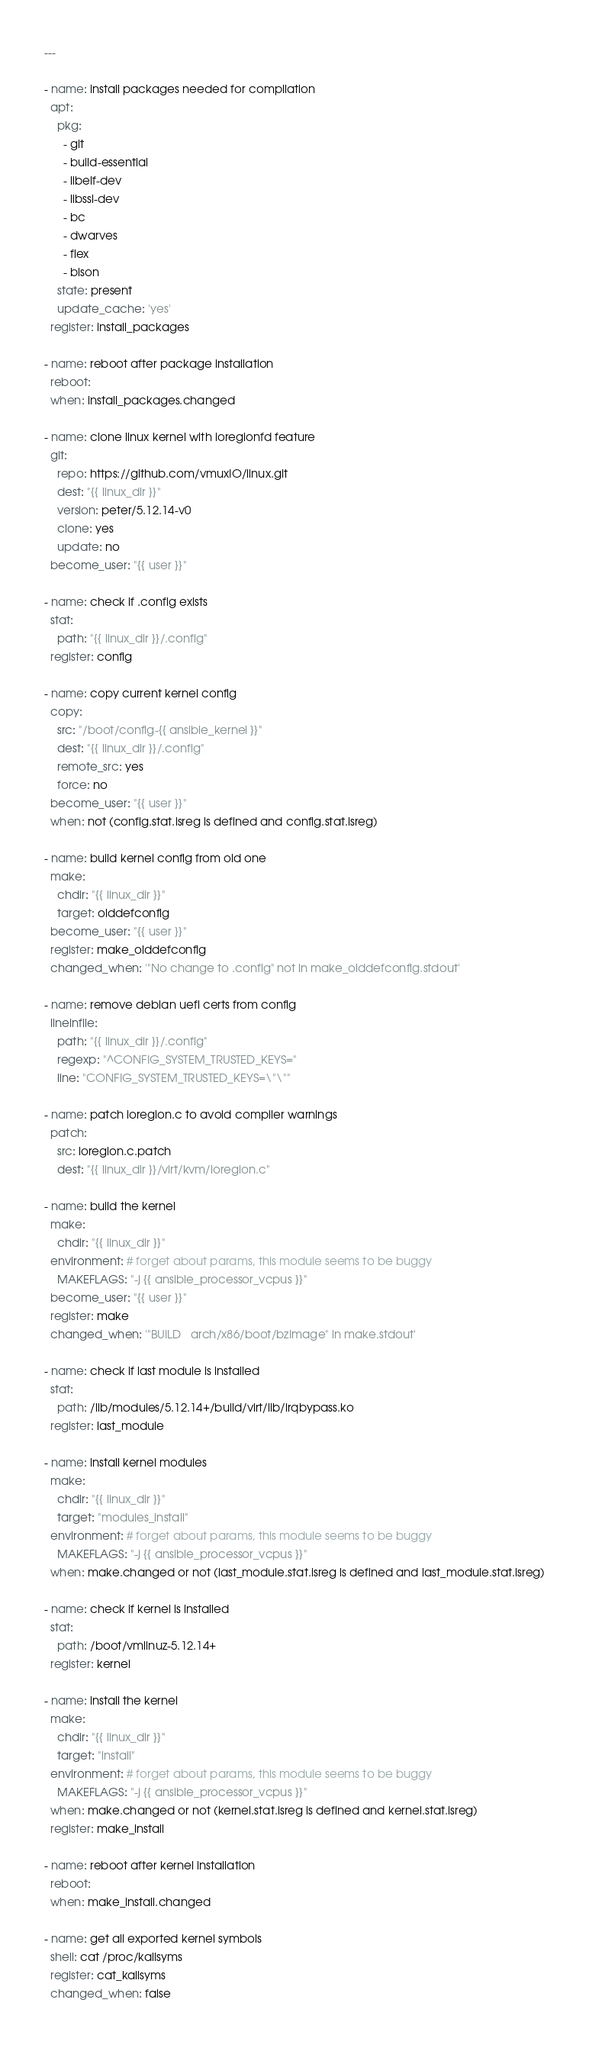Convert code to text. <code><loc_0><loc_0><loc_500><loc_500><_YAML_>---

- name: install packages needed for compilation
  apt:
    pkg:
      - git
      - build-essential
      - libelf-dev
      - libssl-dev
      - bc
      - dwarves
      - flex
      - bison
    state: present
    update_cache: 'yes'
  register: install_packages

- name: reboot after package installation
  reboot:
  when: install_packages.changed

- name: clone linux kernel with ioregionfd feature
  git:
    repo: https://github.com/vmuxIO/linux.git
    dest: "{{ linux_dir }}"
    version: peter/5.12.14-v0
    clone: yes
    update: no
  become_user: "{{ user }}"

- name: check if .config exists
  stat:
    path: "{{ linux_dir }}/.config"
  register: config

- name: copy current kernel config
  copy:
    src: "/boot/config-{{ ansible_kernel }}"
    dest: "{{ linux_dir }}/.config"
    remote_src: yes
    force: no
  become_user: "{{ user }}"
  when: not (config.stat.isreg is defined and config.stat.isreg)

- name: build kernel config from old one
  make:
    chdir: "{{ linux_dir }}"
    target: olddefconfig
  become_user: "{{ user }}"
  register: make_olddefconfig
  changed_when: '"No change to .config" not in make_olddefconfig.stdout'

- name: remove debian uefi certs from config
  lineinfile:
    path: "{{ linux_dir }}/.config"
    regexp: "^CONFIG_SYSTEM_TRUSTED_KEYS="
    line: "CONFIG_SYSTEM_TRUSTED_KEYS=\"\""

- name: patch ioregion.c to avoid compiler warnings
  patch:
    src: ioregion.c.patch
    dest: "{{ linux_dir }}/virt/kvm/ioregion.c"

- name: build the kernel
  make:
    chdir: "{{ linux_dir }}"
  environment: # forget about params, this module seems to be buggy
    MAKEFLAGS: "-j {{ ansible_processor_vcpus }}"
  become_user: "{{ user }}"
  register: make
  changed_when: '"BUILD   arch/x86/boot/bzImage" in make.stdout'

- name: check if last module is installed
  stat:
    path: /lib/modules/5.12.14+/build/virt/lib/irqbypass.ko
  register: last_module

- name: install kernel modules
  make:
    chdir: "{{ linux_dir }}"
    target: "modules_install"
  environment: # forget about params, this module seems to be buggy
    MAKEFLAGS: "-j {{ ansible_processor_vcpus }}"
  when: make.changed or not (last_module.stat.isreg is defined and last_module.stat.isreg)

- name: check if kernel is installed
  stat:
    path: /boot/vmlinuz-5.12.14+
  register: kernel

- name: install the kernel
  make:
    chdir: "{{ linux_dir }}"
    target: "install"
  environment: # forget about params, this module seems to be buggy
    MAKEFLAGS: "-j {{ ansible_processor_vcpus }}"
  when: make.changed or not (kernel.stat.isreg is defined and kernel.stat.isreg)
  register: make_install

- name: reboot after kernel installation
  reboot:
  when: make_install.changed

- name: get all exported kernel symbols
  shell: cat /proc/kallsyms
  register: cat_kallsyms
  changed_when: false
</code> 